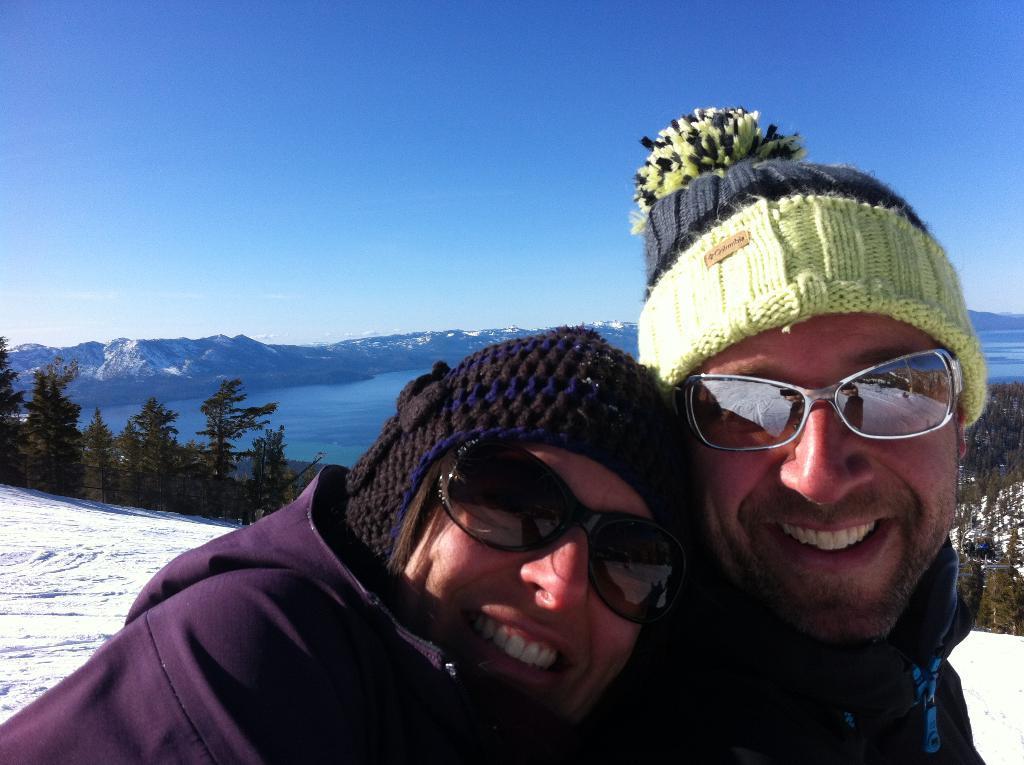How would you summarize this image in a sentence or two? In this picture there are two persons smiling. At the back there are mountains and trees and there is water. At the top there is sky. At the bottom there is snow. 